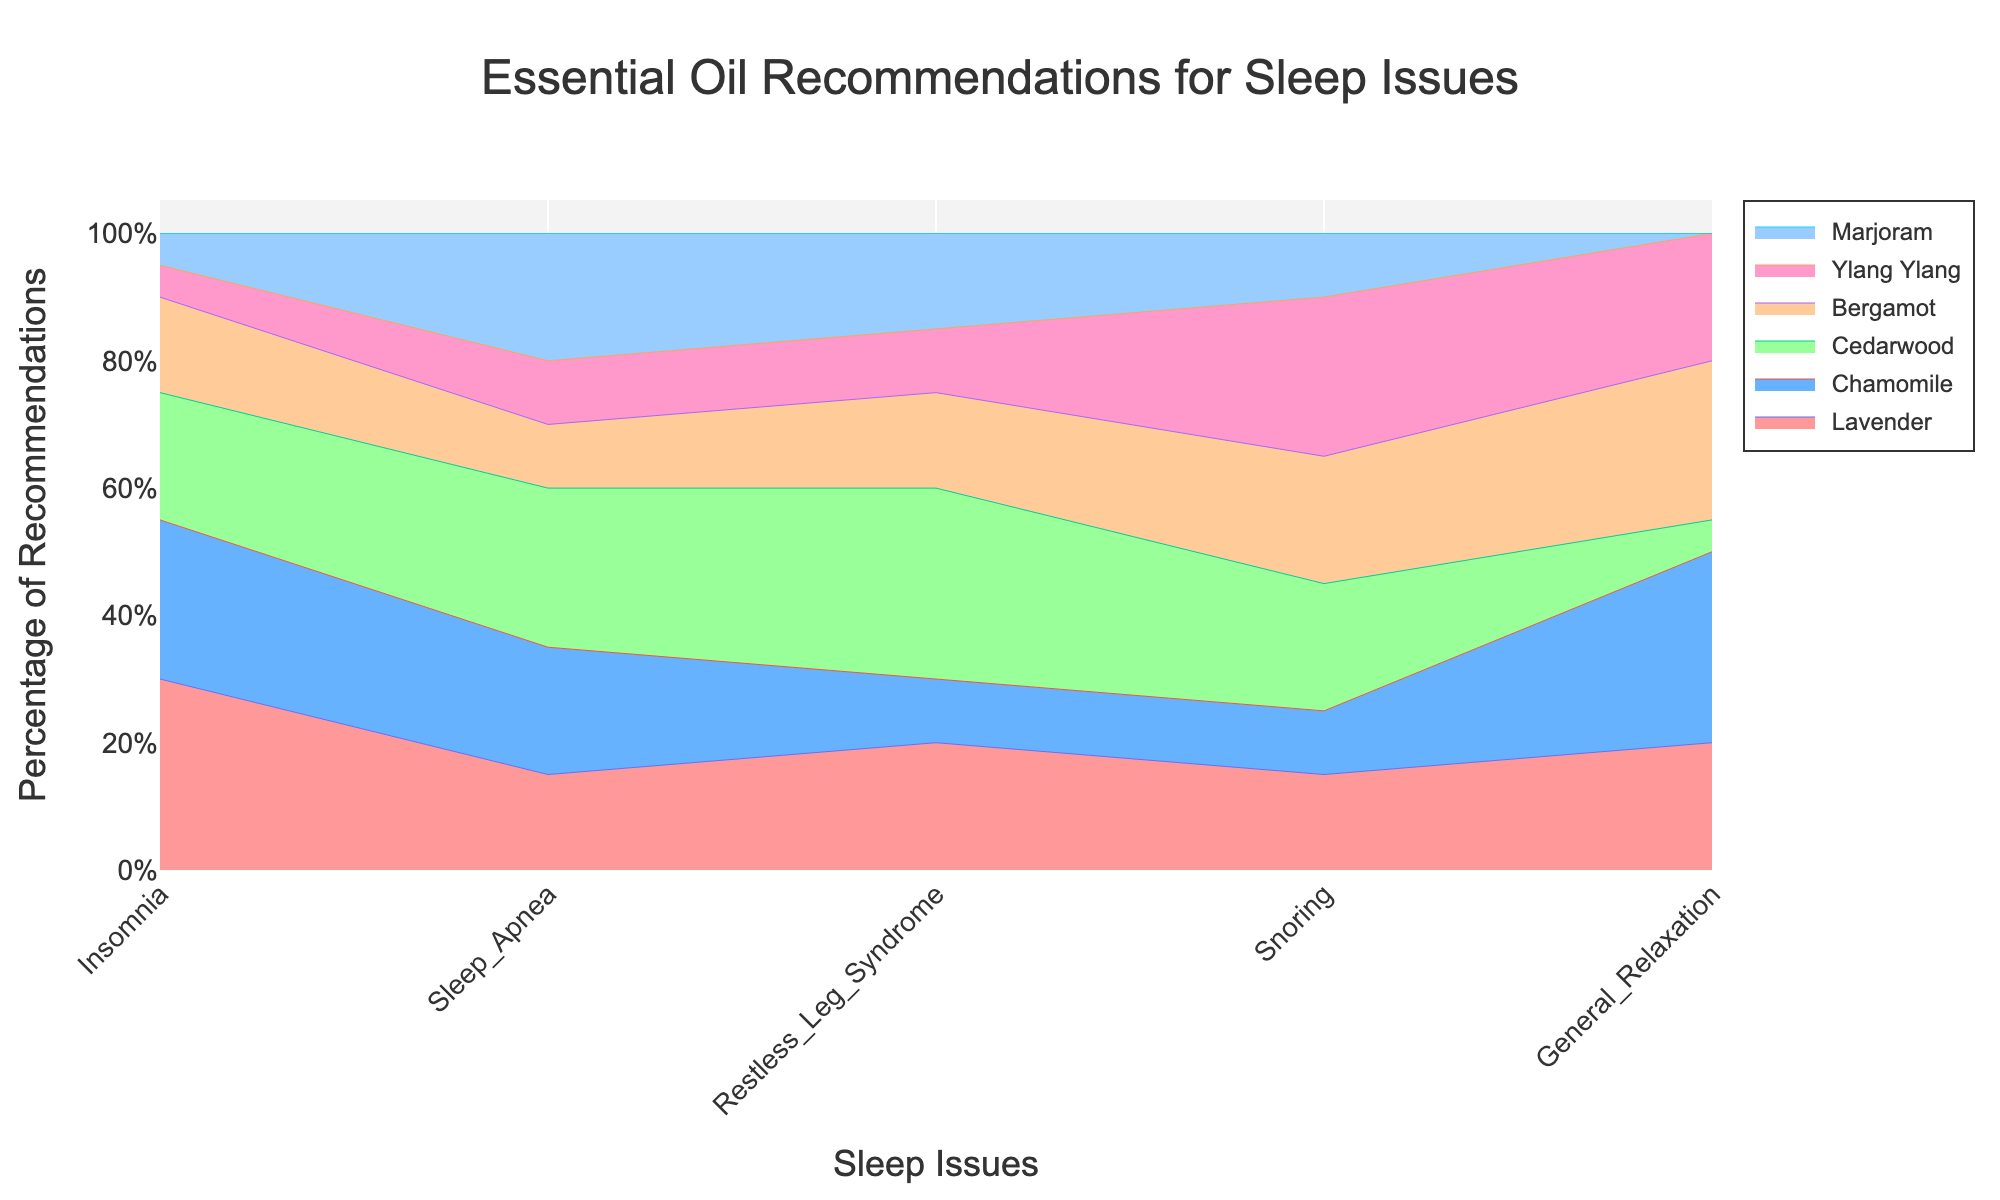What is the title of the figure? The title is usually located at the top of the figure. In this case, it reads "Essential Oil Recommendations for Sleep Issues".
Answer: Essential Oil Recommendations for Sleep Issues Which essential oil has the highest percentage of recommendations for insomnia? By examining the highest segment for the 'Insomnia' category, we find that Lavender has the tallest segment, indicating the highest percentage.
Answer: Lavender What sleep issue has the highest percentage of Marjoram recommendations? Looking across the chart, the tallest segment for Marjoram is observed under "Sleep Apnea" which indicates the highest percentage.
Answer: Sleep Apnea What is the approximate percentage of Lavender recommendations for General Relaxation? By analyzing the segment for Lavender within the "General Relaxation" category, we find it is around 20%.
Answer: 20% Which essential oil is recommended the least for Restless Leg Syndrome? Observing the smallest segment within the "Restless Leg Syndrome" category, we find Chamomile has the smallest area, indicating the least percentage of recommendations.
Answer: Chamomile Between Bergamot and Ylang Ylang, which one has a higher percentage of recommendations for Snoring? Comparing the segments for "Snoring", Bergamot (20%) has a slightly larger segment than Ylang Ylang (25%), indicating a greater percentage of recommendations.
Answer: Ylang Ylang What is the sum of percentages for Cedarwood recommendations across all sleep issues? Adding up the percentages of Cedarwood for each sleep issue: Insomnia (20%) + Sleep Apnea (25%) + Restless Leg Syndrome (30%) + Snoring (20%) + General Relaxation (5%) = 100%.
Answer: 100% For which sleep issue is Chamomile recommended more than any other essential oil? Analyzing the segments, the tallest segment for Chamomile is found within "General Relaxation", indicating it is the most recommended for this sleep issue.
Answer: General Relaxation Which essential oil has a more consistent recommendation percentage across different sleep issues? By examining the consistency of the segments across different categories, Chamomile has relatively even sizes across different sleep issues, indicating consistency in recommendations.
Answer: Chamomile 